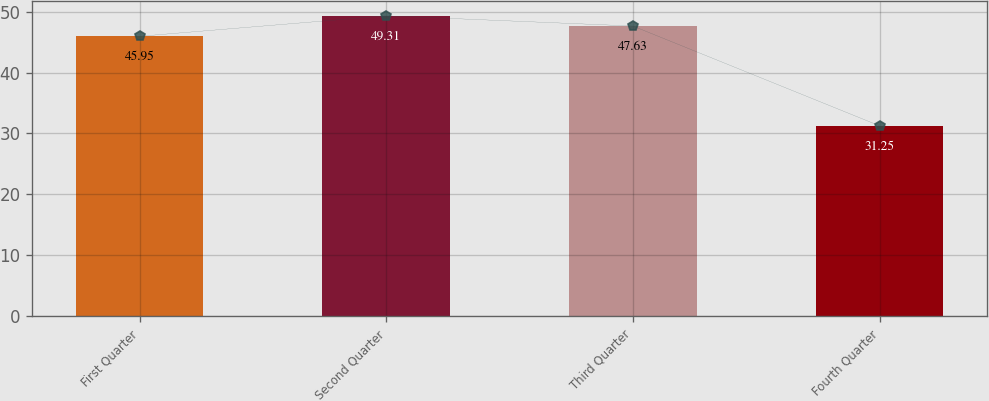Convert chart to OTSL. <chart><loc_0><loc_0><loc_500><loc_500><bar_chart><fcel>First Quarter<fcel>Second Quarter<fcel>Third Quarter<fcel>Fourth Quarter<nl><fcel>45.95<fcel>49.31<fcel>47.63<fcel>31.25<nl></chart> 